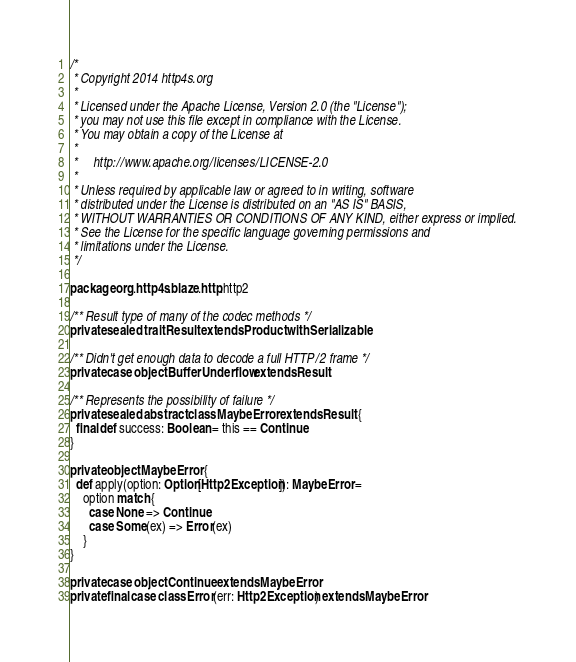<code> <loc_0><loc_0><loc_500><loc_500><_Scala_>/*
 * Copyright 2014 http4s.org
 *
 * Licensed under the Apache License, Version 2.0 (the "License");
 * you may not use this file except in compliance with the License.
 * You may obtain a copy of the License at
 *
 *     http://www.apache.org/licenses/LICENSE-2.0
 *
 * Unless required by applicable law or agreed to in writing, software
 * distributed under the License is distributed on an "AS IS" BASIS,
 * WITHOUT WARRANTIES OR CONDITIONS OF ANY KIND, either express or implied.
 * See the License for the specific language governing permissions and
 * limitations under the License.
 */

package org.http4s.blaze.http.http2

/** Result type of many of the codec methods */
private sealed trait Result extends Product with Serializable

/** Didn't get enough data to decode a full HTTP/2 frame */
private case object BufferUnderflow extends Result

/** Represents the possibility of failure */
private sealed abstract class MaybeError extends Result {
  final def success: Boolean = this == Continue
}

private object MaybeError {
  def apply(option: Option[Http2Exception]): MaybeError =
    option match {
      case None => Continue
      case Some(ex) => Error(ex)
    }
}

private case object Continue extends MaybeError
private final case class Error(err: Http2Exception) extends MaybeError
</code> 